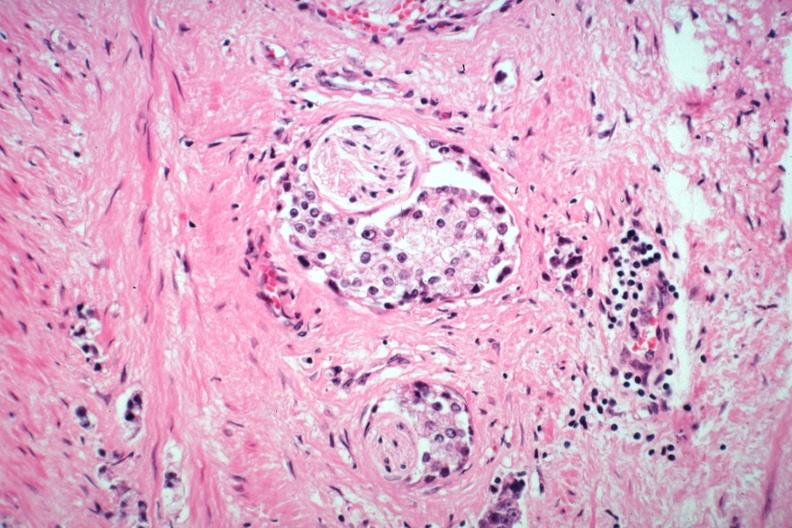does this image show perineural invasion typical prostate carcinoma?
Answer the question using a single word or phrase. Yes 